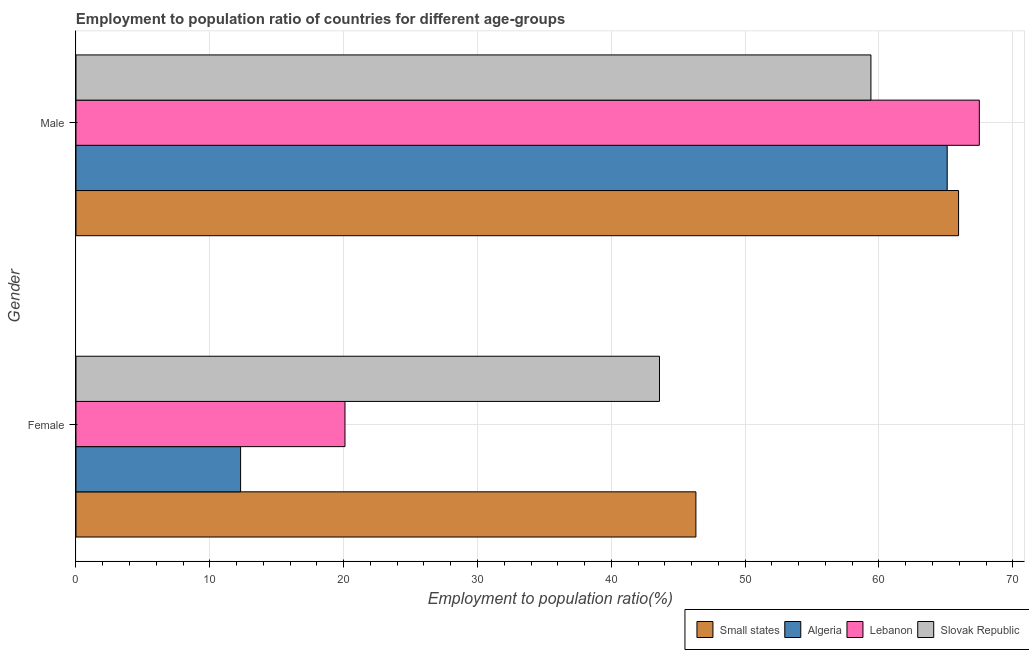How many bars are there on the 2nd tick from the top?
Your answer should be very brief. 4. What is the employment to population ratio(male) in Slovak Republic?
Your answer should be very brief. 59.4. Across all countries, what is the maximum employment to population ratio(male)?
Your answer should be very brief. 67.5. Across all countries, what is the minimum employment to population ratio(female)?
Your answer should be compact. 12.3. In which country was the employment to population ratio(male) maximum?
Offer a very short reply. Lebanon. In which country was the employment to population ratio(female) minimum?
Your answer should be very brief. Algeria. What is the total employment to population ratio(female) in the graph?
Offer a terse response. 122.32. What is the difference between the employment to population ratio(female) in Algeria and that in Slovak Republic?
Make the answer very short. -31.3. What is the difference between the employment to population ratio(male) in Slovak Republic and the employment to population ratio(female) in Small states?
Give a very brief answer. 13.08. What is the average employment to population ratio(male) per country?
Your response must be concise. 64.49. What is the difference between the employment to population ratio(female) and employment to population ratio(male) in Slovak Republic?
Your answer should be compact. -15.8. In how many countries, is the employment to population ratio(female) greater than 22 %?
Ensure brevity in your answer.  2. What is the ratio of the employment to population ratio(female) in Algeria to that in Lebanon?
Your response must be concise. 0.61. Is the employment to population ratio(female) in Lebanon less than that in Small states?
Your response must be concise. Yes. In how many countries, is the employment to population ratio(male) greater than the average employment to population ratio(male) taken over all countries?
Your answer should be very brief. 3. What does the 2nd bar from the top in Female represents?
Your answer should be very brief. Lebanon. What does the 2nd bar from the bottom in Male represents?
Offer a very short reply. Algeria. Are all the bars in the graph horizontal?
Ensure brevity in your answer.  Yes. Does the graph contain grids?
Your answer should be very brief. Yes. Where does the legend appear in the graph?
Ensure brevity in your answer.  Bottom right. What is the title of the graph?
Ensure brevity in your answer.  Employment to population ratio of countries for different age-groups. What is the label or title of the X-axis?
Provide a short and direct response. Employment to population ratio(%). What is the Employment to population ratio(%) of Small states in Female?
Offer a terse response. 46.32. What is the Employment to population ratio(%) in Algeria in Female?
Keep it short and to the point. 12.3. What is the Employment to population ratio(%) in Lebanon in Female?
Give a very brief answer. 20.1. What is the Employment to population ratio(%) of Slovak Republic in Female?
Offer a very short reply. 43.6. What is the Employment to population ratio(%) in Small states in Male?
Provide a short and direct response. 65.95. What is the Employment to population ratio(%) in Algeria in Male?
Offer a very short reply. 65.1. What is the Employment to population ratio(%) of Lebanon in Male?
Your answer should be very brief. 67.5. What is the Employment to population ratio(%) of Slovak Republic in Male?
Make the answer very short. 59.4. Across all Gender, what is the maximum Employment to population ratio(%) in Small states?
Provide a short and direct response. 65.95. Across all Gender, what is the maximum Employment to population ratio(%) in Algeria?
Ensure brevity in your answer.  65.1. Across all Gender, what is the maximum Employment to population ratio(%) of Lebanon?
Provide a succinct answer. 67.5. Across all Gender, what is the maximum Employment to population ratio(%) in Slovak Republic?
Make the answer very short. 59.4. Across all Gender, what is the minimum Employment to population ratio(%) in Small states?
Your response must be concise. 46.32. Across all Gender, what is the minimum Employment to population ratio(%) of Algeria?
Your response must be concise. 12.3. Across all Gender, what is the minimum Employment to population ratio(%) in Lebanon?
Provide a succinct answer. 20.1. Across all Gender, what is the minimum Employment to population ratio(%) of Slovak Republic?
Your answer should be compact. 43.6. What is the total Employment to population ratio(%) of Small states in the graph?
Offer a very short reply. 112.27. What is the total Employment to population ratio(%) in Algeria in the graph?
Your response must be concise. 77.4. What is the total Employment to population ratio(%) of Lebanon in the graph?
Ensure brevity in your answer.  87.6. What is the total Employment to population ratio(%) in Slovak Republic in the graph?
Provide a succinct answer. 103. What is the difference between the Employment to population ratio(%) in Small states in Female and that in Male?
Your answer should be very brief. -19.63. What is the difference between the Employment to population ratio(%) of Algeria in Female and that in Male?
Offer a terse response. -52.8. What is the difference between the Employment to population ratio(%) in Lebanon in Female and that in Male?
Your response must be concise. -47.4. What is the difference between the Employment to population ratio(%) in Slovak Republic in Female and that in Male?
Keep it short and to the point. -15.8. What is the difference between the Employment to population ratio(%) in Small states in Female and the Employment to population ratio(%) in Algeria in Male?
Offer a very short reply. -18.78. What is the difference between the Employment to population ratio(%) in Small states in Female and the Employment to population ratio(%) in Lebanon in Male?
Your response must be concise. -21.18. What is the difference between the Employment to population ratio(%) of Small states in Female and the Employment to population ratio(%) of Slovak Republic in Male?
Ensure brevity in your answer.  -13.08. What is the difference between the Employment to population ratio(%) in Algeria in Female and the Employment to population ratio(%) in Lebanon in Male?
Your response must be concise. -55.2. What is the difference between the Employment to population ratio(%) in Algeria in Female and the Employment to population ratio(%) in Slovak Republic in Male?
Keep it short and to the point. -47.1. What is the difference between the Employment to population ratio(%) in Lebanon in Female and the Employment to population ratio(%) in Slovak Republic in Male?
Keep it short and to the point. -39.3. What is the average Employment to population ratio(%) of Small states per Gender?
Your answer should be compact. 56.14. What is the average Employment to population ratio(%) of Algeria per Gender?
Make the answer very short. 38.7. What is the average Employment to population ratio(%) of Lebanon per Gender?
Provide a succinct answer. 43.8. What is the average Employment to population ratio(%) in Slovak Republic per Gender?
Keep it short and to the point. 51.5. What is the difference between the Employment to population ratio(%) of Small states and Employment to population ratio(%) of Algeria in Female?
Provide a short and direct response. 34.02. What is the difference between the Employment to population ratio(%) of Small states and Employment to population ratio(%) of Lebanon in Female?
Make the answer very short. 26.22. What is the difference between the Employment to population ratio(%) of Small states and Employment to population ratio(%) of Slovak Republic in Female?
Make the answer very short. 2.72. What is the difference between the Employment to population ratio(%) of Algeria and Employment to population ratio(%) of Slovak Republic in Female?
Make the answer very short. -31.3. What is the difference between the Employment to population ratio(%) of Lebanon and Employment to population ratio(%) of Slovak Republic in Female?
Provide a succinct answer. -23.5. What is the difference between the Employment to population ratio(%) in Small states and Employment to population ratio(%) in Algeria in Male?
Make the answer very short. 0.85. What is the difference between the Employment to population ratio(%) in Small states and Employment to population ratio(%) in Lebanon in Male?
Offer a terse response. -1.55. What is the difference between the Employment to population ratio(%) of Small states and Employment to population ratio(%) of Slovak Republic in Male?
Keep it short and to the point. 6.55. What is the ratio of the Employment to population ratio(%) of Small states in Female to that in Male?
Your response must be concise. 0.7. What is the ratio of the Employment to population ratio(%) of Algeria in Female to that in Male?
Your response must be concise. 0.19. What is the ratio of the Employment to population ratio(%) of Lebanon in Female to that in Male?
Keep it short and to the point. 0.3. What is the ratio of the Employment to population ratio(%) in Slovak Republic in Female to that in Male?
Keep it short and to the point. 0.73. What is the difference between the highest and the second highest Employment to population ratio(%) of Small states?
Offer a terse response. 19.63. What is the difference between the highest and the second highest Employment to population ratio(%) in Algeria?
Give a very brief answer. 52.8. What is the difference between the highest and the second highest Employment to population ratio(%) of Lebanon?
Keep it short and to the point. 47.4. What is the difference between the highest and the lowest Employment to population ratio(%) in Small states?
Your answer should be compact. 19.63. What is the difference between the highest and the lowest Employment to population ratio(%) of Algeria?
Offer a very short reply. 52.8. What is the difference between the highest and the lowest Employment to population ratio(%) in Lebanon?
Offer a very short reply. 47.4. What is the difference between the highest and the lowest Employment to population ratio(%) of Slovak Republic?
Make the answer very short. 15.8. 